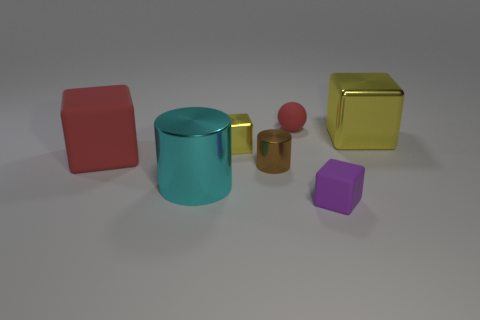Add 1 cyan metal cylinders. How many objects exist? 8 Subtract all cubes. How many objects are left? 3 Add 6 small purple rubber cylinders. How many small purple rubber cylinders exist? 6 Subtract 0 gray blocks. How many objects are left? 7 Subtract all cubes. Subtract all cyan cylinders. How many objects are left? 2 Add 7 small red rubber objects. How many small red rubber objects are left? 8 